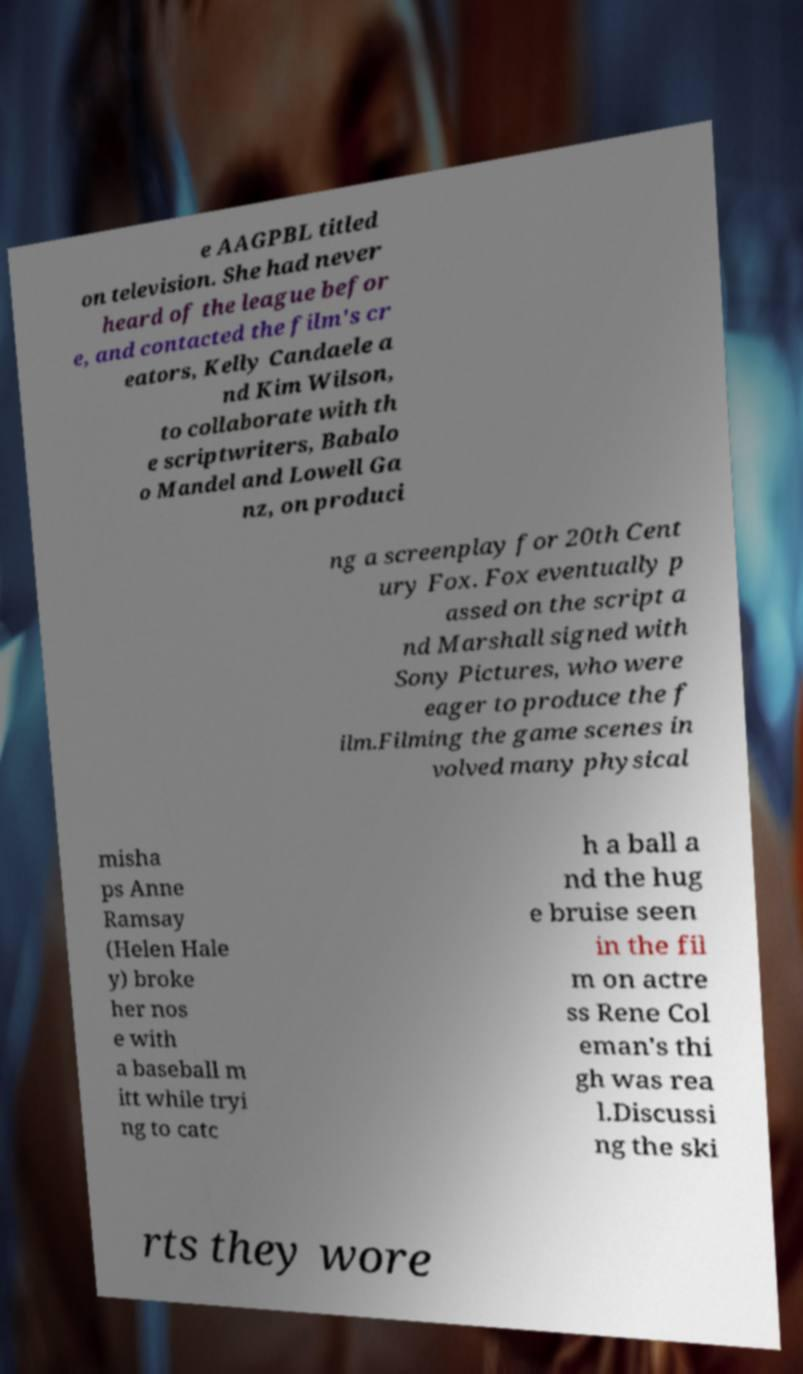Please identify and transcribe the text found in this image. e AAGPBL titled on television. She had never heard of the league befor e, and contacted the film's cr eators, Kelly Candaele a nd Kim Wilson, to collaborate with th e scriptwriters, Babalo o Mandel and Lowell Ga nz, on produci ng a screenplay for 20th Cent ury Fox. Fox eventually p assed on the script a nd Marshall signed with Sony Pictures, who were eager to produce the f ilm.Filming the game scenes in volved many physical misha ps Anne Ramsay (Helen Hale y) broke her nos e with a baseball m itt while tryi ng to catc h a ball a nd the hug e bruise seen in the fil m on actre ss Rene Col eman's thi gh was rea l.Discussi ng the ski rts they wore 